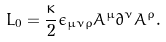Convert formula to latex. <formula><loc_0><loc_0><loc_500><loc_500>L _ { 0 } = \frac { \kappa } { 2 } \epsilon _ { \mu \nu \rho } A ^ { \mu } \partial ^ { \nu } A ^ { \rho } .</formula> 